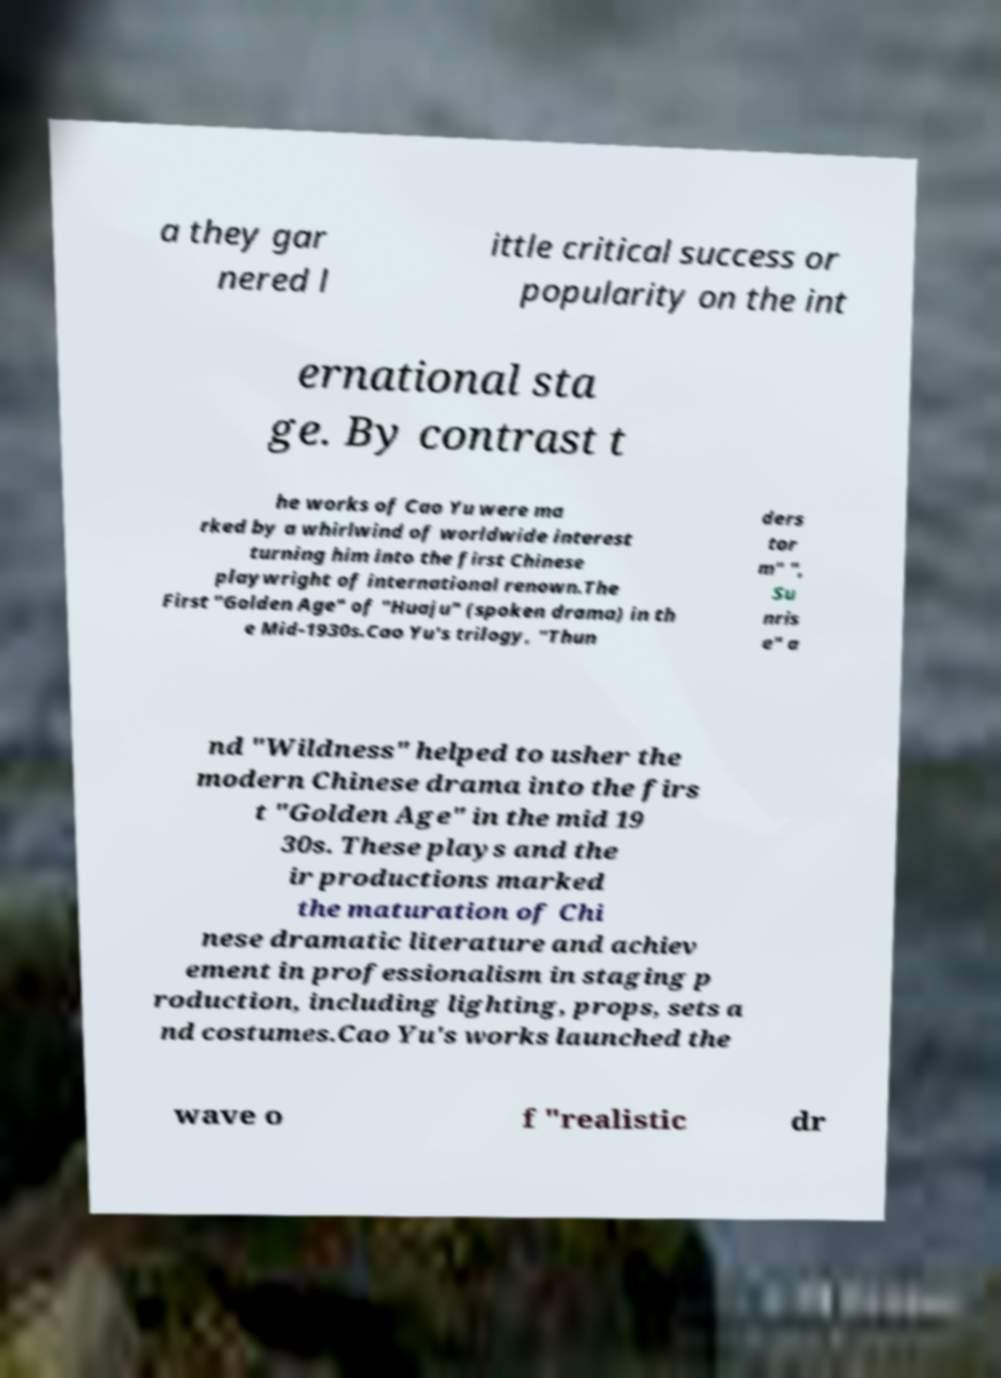Please read and relay the text visible in this image. What does it say? a they gar nered l ittle critical success or popularity on the int ernational sta ge. By contrast t he works of Cao Yu were ma rked by a whirlwind of worldwide interest turning him into the first Chinese playwright of international renown.The First "Golden Age" of "Huaju" (spoken drama) in th e Mid-1930s.Cao Yu's trilogy, "Thun ders tor m" ", Su nris e" a nd "Wildness" helped to usher the modern Chinese drama into the firs t "Golden Age" in the mid 19 30s. These plays and the ir productions marked the maturation of Chi nese dramatic literature and achiev ement in professionalism in staging p roduction, including lighting, props, sets a nd costumes.Cao Yu's works launched the wave o f "realistic dr 